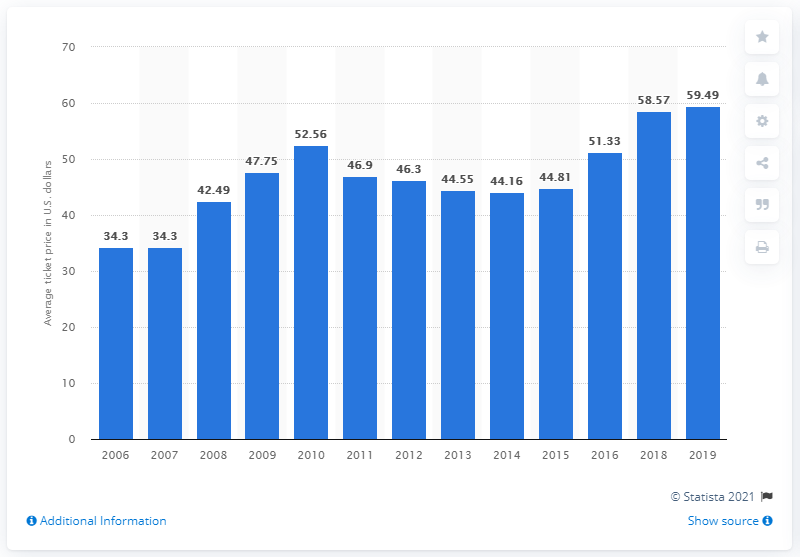Specify some key components in this picture. The average ticket price for Cubs games in 2019 was $59.49. 